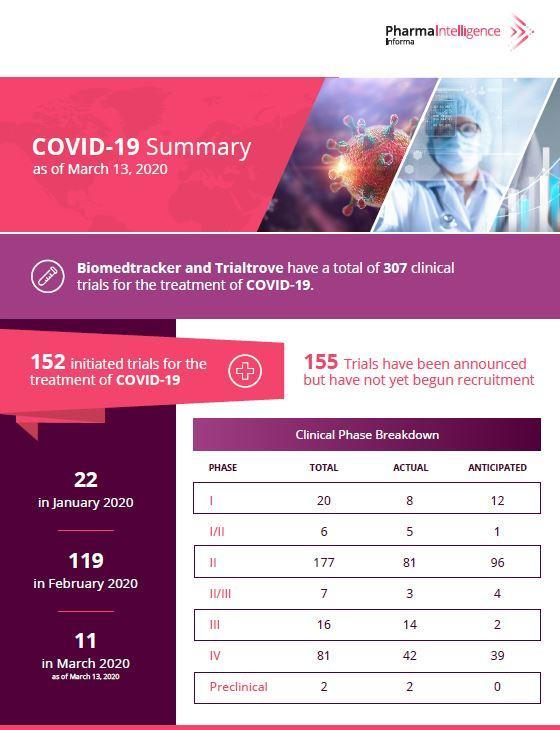What are the number of clinical trials that are initiated and that are just announced respectively?
Answer the question with a short phrase. 152, 155 What is the total number of clinical trials that are initiated in January and February combined? 141 What is the total number of actual clinical trials taking place in various phases? 155 At what stage are the most number of actual clinical trials taking place? phase II What is the total number of clinical trial that are in phase one and phase two? 197 What is the total number of anticipated clinical trials according to the table? 309 What is the total number of clinical trials that are initiated in March and February combined? 130 In which month did more than 100 of the clinical trials begin? February In which month did least of the clinical trials begin? in march At what stage are the least number of clinical trials taking place? preclinical What is the total number of anticipated clinical trials? 154 What is the total number of clinical trials that are initiated in January and March combined? 33 At what stage are more clinical trials taking place? phase II In which month did most of the clinical trials begin? February 